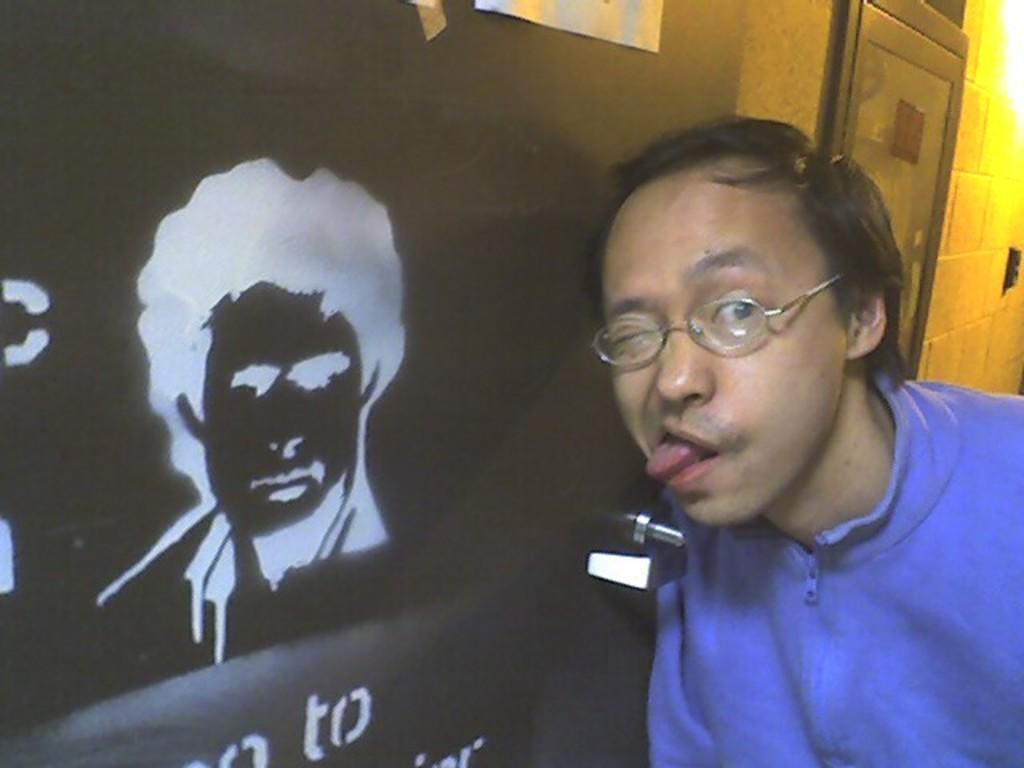In one or two sentences, can you explain what this image depicts? In a given image i can see a person and behind him i can see a object with some text. 